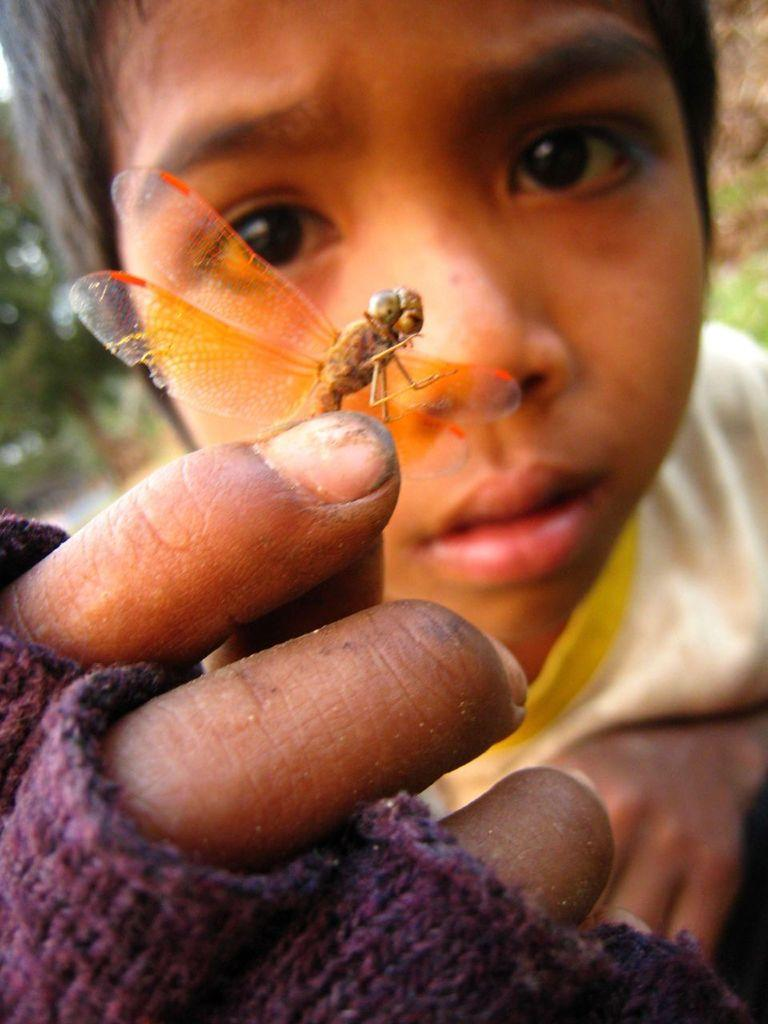Who is present in the image? There is a man in the picture. What is the man wearing on his upper body? The man is wearing a t-shirt. What accessory is the man wearing on his face? The man is wearing glasses. What is the man holding in his hand? The man is holding an inset. What type of natural environment can be seen in the background? There is grass and trees visible in the background. What type of legal advice is the man providing in the image? There is no indication in the image that the man is providing legal advice or acting as a lawyer. 